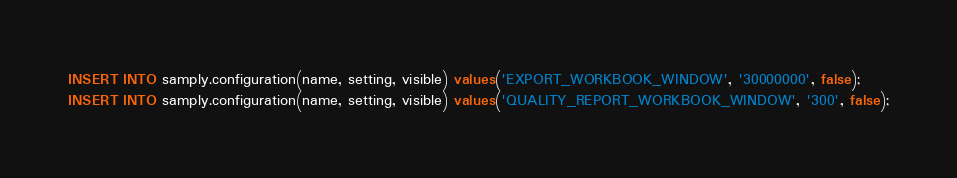Convert code to text. <code><loc_0><loc_0><loc_500><loc_500><_SQL_>INSERT INTO samply.configuration(name, setting, visible) values('EXPORT_WORKBOOK_WINDOW', '30000000', false);
INSERT INTO samply.configuration(name, setting, visible) values('QUALITY_REPORT_WORKBOOK_WINDOW', '300', false);
</code> 